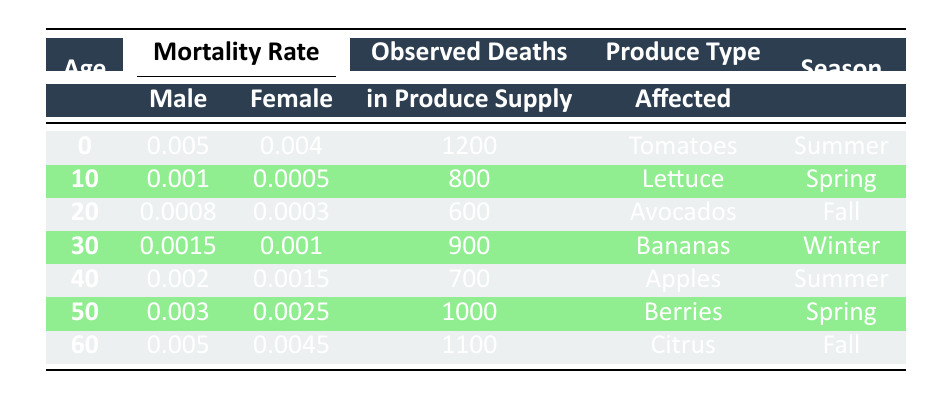What is the observed death count for tomatoes during summer? The table indicates that the observed death in produce supply for tomatoes during summer is specifically listed in the row corresponding to age 0. That value is 1200.
Answer: 1200 Which produce type was affected the most by mortality rate in spring? To find the produce type affected by mortality in spring, we look at the rows that list the spring season. The affected produce types in spring are Lettuce (800 deaths) and Berries (1000 deaths). Comparing these values, Berries has the higher observed death count.
Answer: Berries What is the total observed death count for all produce types during the summer season? The table illustrates that the produce types affected during summer are Tomatoes (1200 deaths) and Apples (700 deaths). Summing these values gives us 1200 + 700 = 1900.
Answer: 1900 Is the male mortality rate for age 50 higher than for age 40? The male mortality rate for age 50 is 0.003 while for age 40 it is 0.002. Since 0.003 is greater than 0.002, it confirms that the male mortality rate for age 50 is indeed higher.
Answer: Yes What is the average observed death count for all produce types during the fall season? The table shows that the produce affected in the fall season includes Avocados (600 deaths) and Citrus (1100 deaths). The sum of these is 600 + 1100 = 1700. There are 2 data points, so the average is 1700 / 2 = 850.
Answer: 850 What is the difference in the female mortality rate between age 0 and age 60? The female mortality rate at age 0 is 0.004 and at age 60 is 0.0045. To find the difference, we subtract 0.004 from 0.0045, resulting in 0.0045 - 0.004 = 0.0005.
Answer: 0.0005 Is the male mortality rate for age 30 higher than the female mortality rate for age 50? The male mortality rate for age 30 is 0.0015, while the female mortality rate for age 50 is 0.0025. Since 0.0015 is lower than 0.0025, the answer is no.
Answer: No What is the highest observed death count recorded among all produce types in this table? By inspecting the observed death counts for each produce type, we find: Tomatoes (1200), Lettuce (800), Avocados (600), Bananas (900), Apples (700), Berries (1000), and Citrus (1100). The highest among these is 1200 for tomatoes.
Answer: 1200 